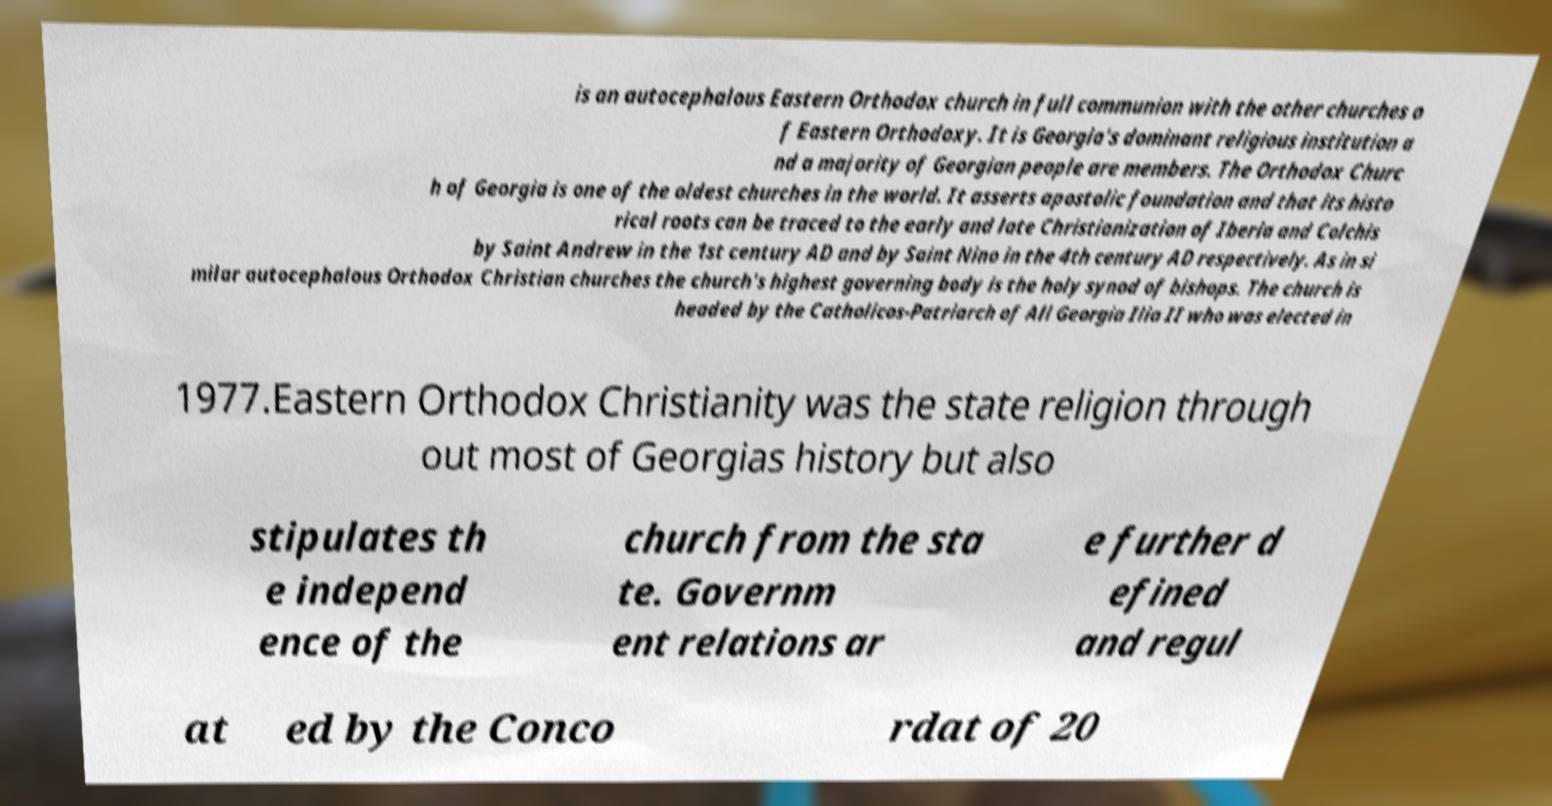Please identify and transcribe the text found in this image. is an autocephalous Eastern Orthodox church in full communion with the other churches o f Eastern Orthodoxy. It is Georgia's dominant religious institution a nd a majority of Georgian people are members. The Orthodox Churc h of Georgia is one of the oldest churches in the world. It asserts apostolic foundation and that its histo rical roots can be traced to the early and late Christianization of Iberia and Colchis by Saint Andrew in the 1st century AD and by Saint Nino in the 4th century AD respectively. As in si milar autocephalous Orthodox Christian churches the church's highest governing body is the holy synod of bishops. The church is headed by the Catholicos-Patriarch of All Georgia Ilia II who was elected in 1977.Eastern Orthodox Christianity was the state religion through out most of Georgias history but also stipulates th e independ ence of the church from the sta te. Governm ent relations ar e further d efined and regul at ed by the Conco rdat of 20 